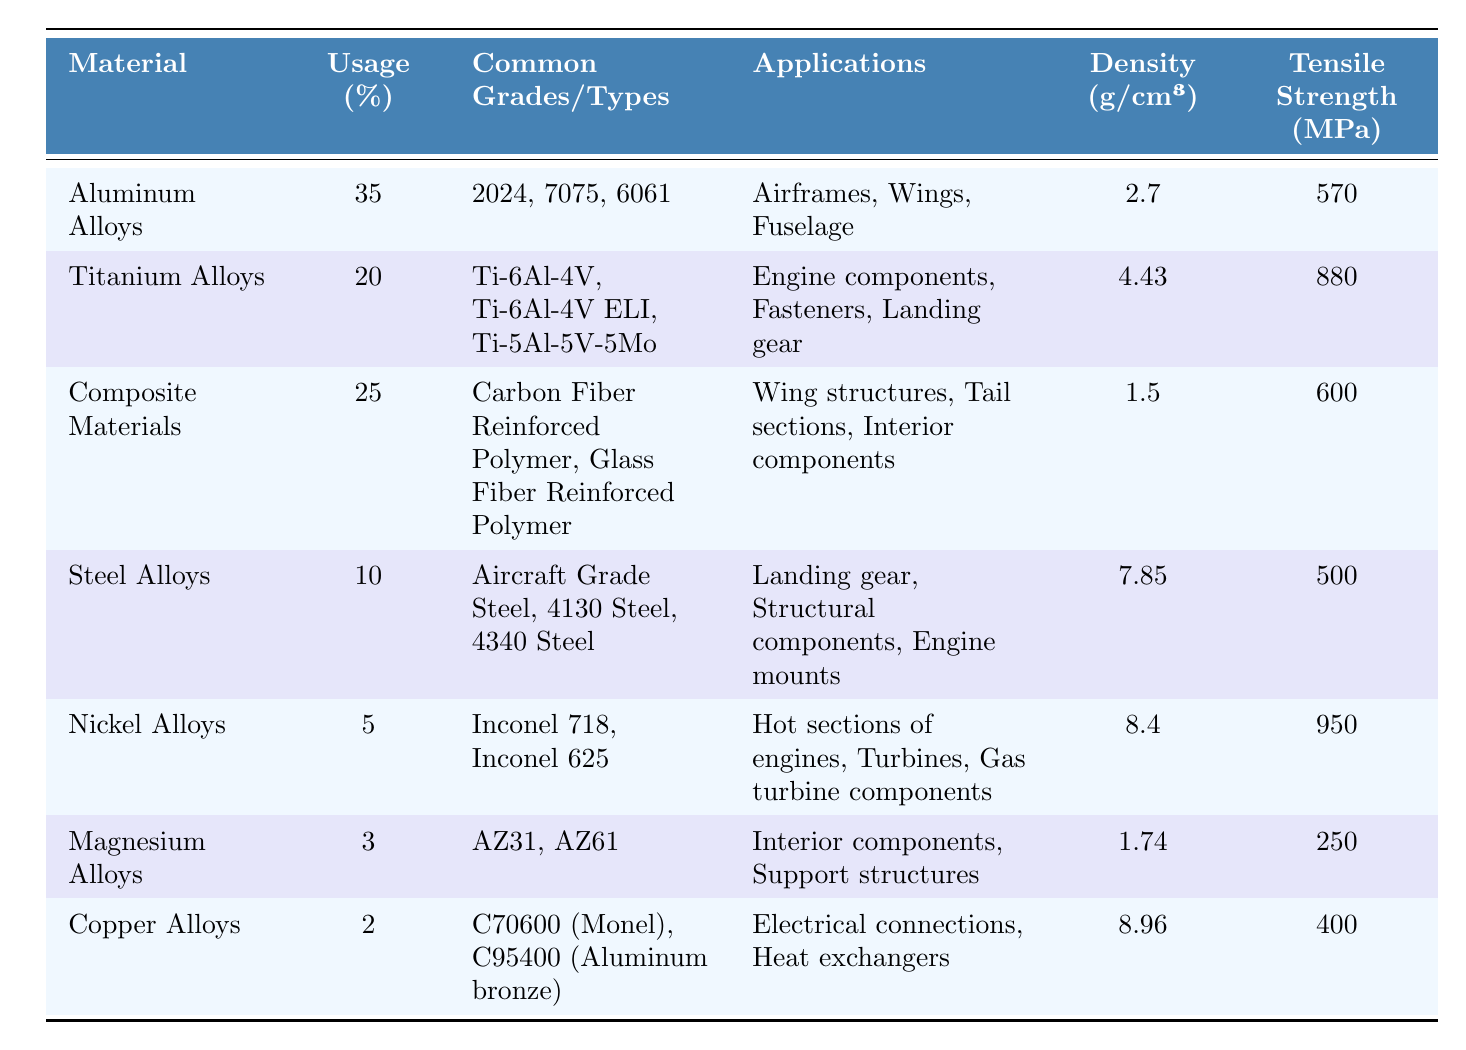What material has the highest usage percentage in aerospace engineering? By looking at the "Usage (%)" column, I can see that Aluminum Alloys have the highest percentage at 35%.
Answer: Aluminum Alloys What is the tensile strength of Titanium Alloys? The "Tensile Strength (MPa)" column shows that Titanium Alloys have a tensile strength of 880 MPa.
Answer: 880 MPa How many materials have a usage percentage greater than 20%? From the "Usage (%)" column, I count three materials: Aluminum Alloys (35%), Composite Materials (25%), and Titanium Alloys (20%).
Answer: 3 Which material has the lowest tensile strength and what is that value? The list indicates that Magnesium Alloys have the lowest tensile strength at 250 MPa in the "Tensile Strength (MPa)" column.
Answer: 250 MPa Is there a material with a usage percentage of 10% or less? Yes, Steel Alloys (10%), Nickel Alloys (5%), Magnesium Alloys (3%), and Copper Alloys (2%) all have 10% or less usage percentage.
Answer: Yes What is the average density of all the materials listed in the table? To find the average density, first convert all densities to a numeric format: 2.7, 4.43, 1.5, 7.85, 8.4, 1.74, 8.96. Then sum them up: 2.7 + 4.43 + 1.5 + 7.85 + 8.4 + 1.74 + 8.96 = 35.68, and divide by 7 (the number of materials), which gives approximately 5.1 g/cm³.
Answer: 5.1 g/cm³ Which material has the highest density among the options provided? By comparing the densities in the "Density (g/cm³)" column, Nickel Alloys have the highest density at 8.4 g/cm³.
Answer: Nickel Alloys What total percentage of materials is accounted for by Composite Materials and Titanium Alloys combined? Looking at the "Usage (%)" column, Composite Materials (25%) and Titanium Alloys (20%) add up to 45% (25 + 20 = 45).
Answer: 45% Are copper alloys commonly used in structural components of aircraft? The applications listed for Copper Alloys show they are used for electrical connections and heat exchangers, not structural components, which indicates they are not commonly used for that purpose.
Answer: No How does the tensile strength of Nickel Alloys compare to that of Steel Alloys? Nickel Alloys have a tensile strength of 950 MPa, while Steel Alloys have a tensile strength of 500 MPa. This means Nickel Alloys are stronger.
Answer: Higher tensile strength for Nickel Alloys What percentage of materials in the survey are classified as Aluminum Alloys and Copper Alloys? From the table, Aluminum Alloys have 35% and Copper Alloys have 2%, adding up to 37% (35 + 2 = 37).
Answer: 37% 